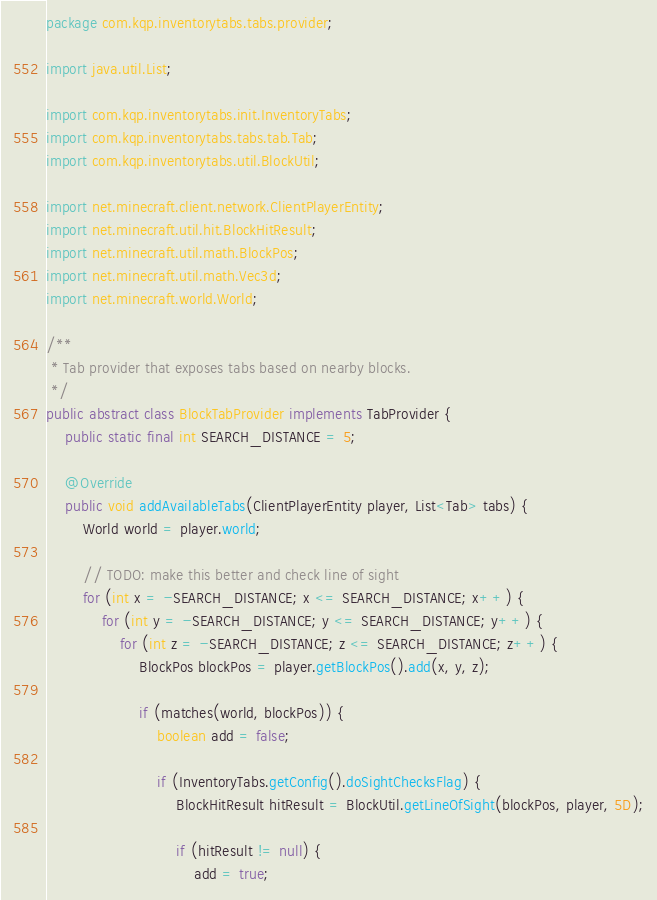Convert code to text. <code><loc_0><loc_0><loc_500><loc_500><_Java_>package com.kqp.inventorytabs.tabs.provider;

import java.util.List;

import com.kqp.inventorytabs.init.InventoryTabs;
import com.kqp.inventorytabs.tabs.tab.Tab;
import com.kqp.inventorytabs.util.BlockUtil;

import net.minecraft.client.network.ClientPlayerEntity;
import net.minecraft.util.hit.BlockHitResult;
import net.minecraft.util.math.BlockPos;
import net.minecraft.util.math.Vec3d;
import net.minecraft.world.World;

/**
 * Tab provider that exposes tabs based on nearby blocks.
 */
public abstract class BlockTabProvider implements TabProvider {
    public static final int SEARCH_DISTANCE = 5;

    @Override
    public void addAvailableTabs(ClientPlayerEntity player, List<Tab> tabs) {
        World world = player.world;

        // TODO: make this better and check line of sight
        for (int x = -SEARCH_DISTANCE; x <= SEARCH_DISTANCE; x++) {
            for (int y = -SEARCH_DISTANCE; y <= SEARCH_DISTANCE; y++) {
                for (int z = -SEARCH_DISTANCE; z <= SEARCH_DISTANCE; z++) {
                    BlockPos blockPos = player.getBlockPos().add(x, y, z);

                    if (matches(world, blockPos)) {
                        boolean add = false;

                        if (InventoryTabs.getConfig().doSightChecksFlag) {
                            BlockHitResult hitResult = BlockUtil.getLineOfSight(blockPos, player, 5D);

                            if (hitResult != null) {
                                add = true;</code> 